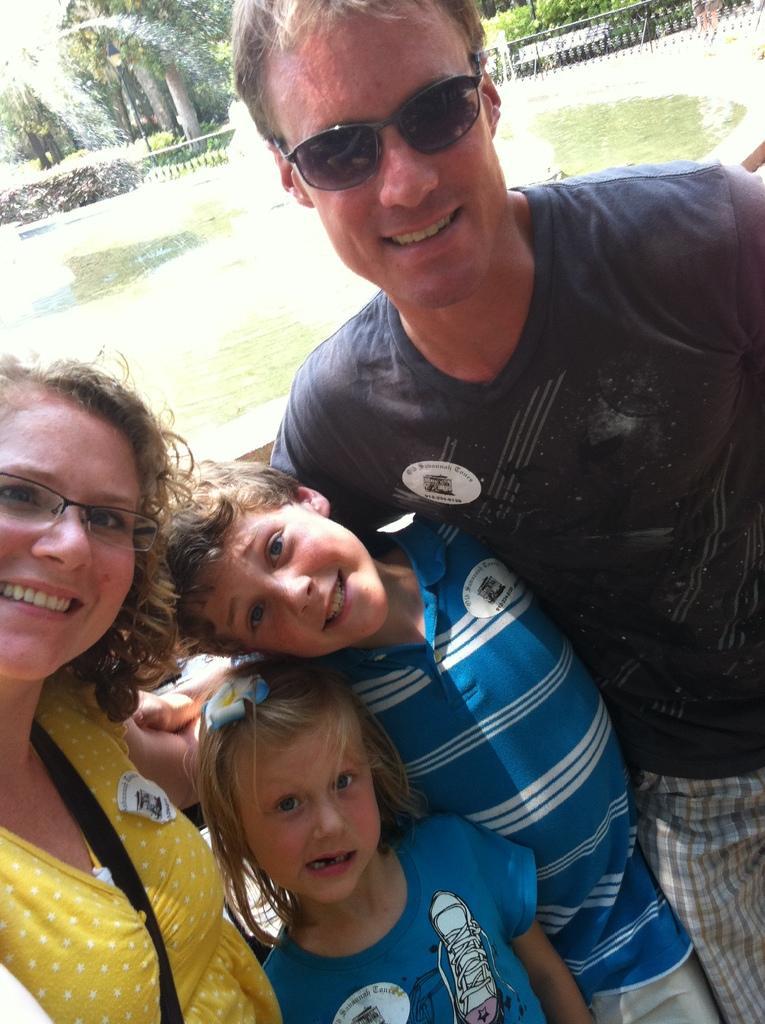Could you give a brief overview of what you see in this image? In this image we can see two adults and two children, in the background there is a fountain and some trees. 